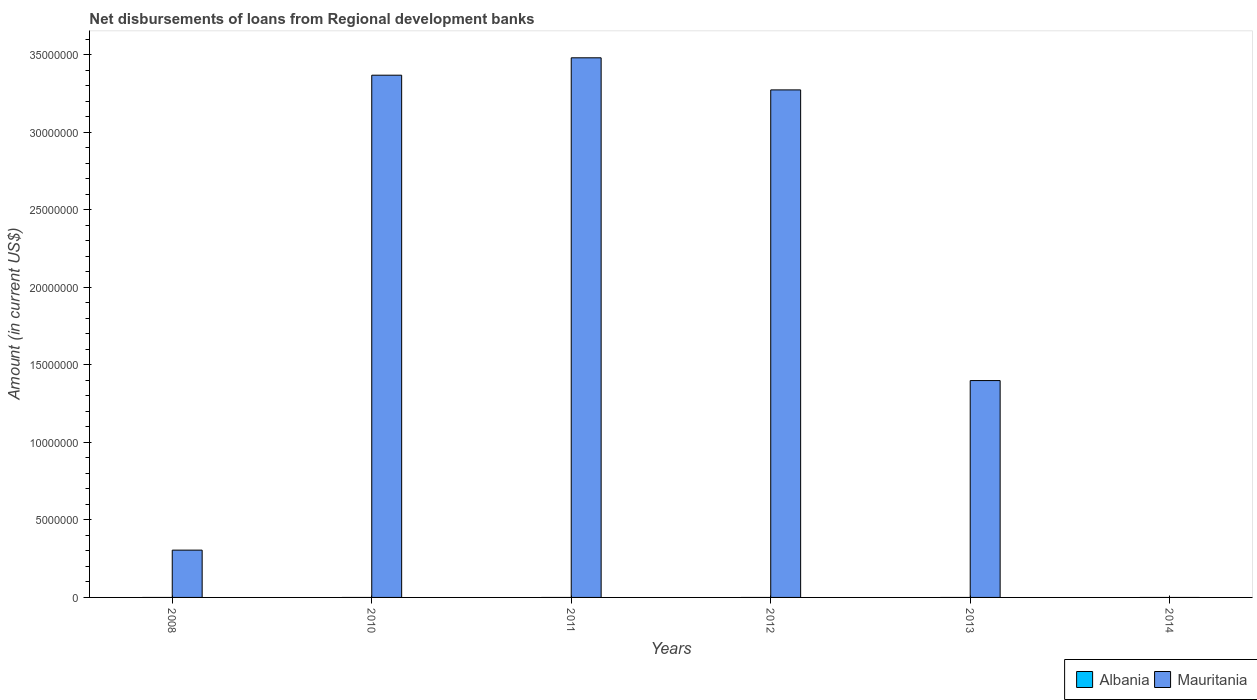Are the number of bars per tick equal to the number of legend labels?
Make the answer very short. No. How many bars are there on the 2nd tick from the left?
Your answer should be very brief. 1. How many bars are there on the 3rd tick from the right?
Provide a succinct answer. 1. What is the label of the 6th group of bars from the left?
Offer a very short reply. 2014. In how many cases, is the number of bars for a given year not equal to the number of legend labels?
Give a very brief answer. 6. What is the amount of disbursements of loans from regional development banks in Mauritania in 2010?
Your answer should be very brief. 3.37e+07. Across all years, what is the maximum amount of disbursements of loans from regional development banks in Mauritania?
Keep it short and to the point. 3.48e+07. In which year was the amount of disbursements of loans from regional development banks in Mauritania maximum?
Provide a succinct answer. 2011. What is the total amount of disbursements of loans from regional development banks in Mauritania in the graph?
Ensure brevity in your answer.  1.18e+08. What is the difference between the amount of disbursements of loans from regional development banks in Mauritania in 2008 and that in 2011?
Make the answer very short. -3.18e+07. What is the difference between the amount of disbursements of loans from regional development banks in Mauritania in 2011 and the amount of disbursements of loans from regional development banks in Albania in 2012?
Your answer should be very brief. 3.48e+07. What is the average amount of disbursements of loans from regional development banks in Albania per year?
Keep it short and to the point. 0. In how many years, is the amount of disbursements of loans from regional development banks in Albania greater than 8000000 US$?
Ensure brevity in your answer.  0. What is the ratio of the amount of disbursements of loans from regional development banks in Mauritania in 2010 to that in 2013?
Offer a terse response. 2.41. Is the amount of disbursements of loans from regional development banks in Mauritania in 2011 less than that in 2012?
Offer a very short reply. No. What is the difference between the highest and the second highest amount of disbursements of loans from regional development banks in Mauritania?
Keep it short and to the point. 1.12e+06. What is the difference between the highest and the lowest amount of disbursements of loans from regional development banks in Mauritania?
Your answer should be very brief. 3.48e+07. In how many years, is the amount of disbursements of loans from regional development banks in Albania greater than the average amount of disbursements of loans from regional development banks in Albania taken over all years?
Keep it short and to the point. 0. Is the sum of the amount of disbursements of loans from regional development banks in Mauritania in 2012 and 2013 greater than the maximum amount of disbursements of loans from regional development banks in Albania across all years?
Your answer should be very brief. Yes. Are the values on the major ticks of Y-axis written in scientific E-notation?
Provide a short and direct response. No. Does the graph contain grids?
Ensure brevity in your answer.  No. Where does the legend appear in the graph?
Your response must be concise. Bottom right. What is the title of the graph?
Make the answer very short. Net disbursements of loans from Regional development banks. Does "Lesotho" appear as one of the legend labels in the graph?
Give a very brief answer. No. What is the label or title of the X-axis?
Offer a terse response. Years. What is the label or title of the Y-axis?
Offer a very short reply. Amount (in current US$). What is the Amount (in current US$) in Albania in 2008?
Provide a short and direct response. 0. What is the Amount (in current US$) in Mauritania in 2008?
Your answer should be very brief. 3.05e+06. What is the Amount (in current US$) of Albania in 2010?
Your response must be concise. 0. What is the Amount (in current US$) of Mauritania in 2010?
Make the answer very short. 3.37e+07. What is the Amount (in current US$) in Albania in 2011?
Keep it short and to the point. 0. What is the Amount (in current US$) of Mauritania in 2011?
Your response must be concise. 3.48e+07. What is the Amount (in current US$) in Albania in 2012?
Make the answer very short. 0. What is the Amount (in current US$) of Mauritania in 2012?
Ensure brevity in your answer.  3.27e+07. What is the Amount (in current US$) in Albania in 2013?
Your answer should be very brief. 0. What is the Amount (in current US$) of Mauritania in 2013?
Your response must be concise. 1.40e+07. What is the Amount (in current US$) in Albania in 2014?
Your response must be concise. 0. What is the Amount (in current US$) of Mauritania in 2014?
Provide a succinct answer. 0. Across all years, what is the maximum Amount (in current US$) of Mauritania?
Offer a very short reply. 3.48e+07. Across all years, what is the minimum Amount (in current US$) of Mauritania?
Offer a very short reply. 0. What is the total Amount (in current US$) in Albania in the graph?
Your response must be concise. 0. What is the total Amount (in current US$) of Mauritania in the graph?
Keep it short and to the point. 1.18e+08. What is the difference between the Amount (in current US$) of Mauritania in 2008 and that in 2010?
Offer a very short reply. -3.06e+07. What is the difference between the Amount (in current US$) in Mauritania in 2008 and that in 2011?
Your answer should be very brief. -3.18e+07. What is the difference between the Amount (in current US$) in Mauritania in 2008 and that in 2012?
Offer a terse response. -2.97e+07. What is the difference between the Amount (in current US$) of Mauritania in 2008 and that in 2013?
Provide a short and direct response. -1.09e+07. What is the difference between the Amount (in current US$) in Mauritania in 2010 and that in 2011?
Provide a succinct answer. -1.12e+06. What is the difference between the Amount (in current US$) in Mauritania in 2010 and that in 2012?
Provide a succinct answer. 9.49e+05. What is the difference between the Amount (in current US$) of Mauritania in 2010 and that in 2013?
Your answer should be very brief. 1.97e+07. What is the difference between the Amount (in current US$) in Mauritania in 2011 and that in 2012?
Provide a succinct answer. 2.07e+06. What is the difference between the Amount (in current US$) of Mauritania in 2011 and that in 2013?
Provide a short and direct response. 2.08e+07. What is the difference between the Amount (in current US$) of Mauritania in 2012 and that in 2013?
Provide a short and direct response. 1.88e+07. What is the average Amount (in current US$) of Albania per year?
Your answer should be very brief. 0. What is the average Amount (in current US$) of Mauritania per year?
Your response must be concise. 1.97e+07. What is the ratio of the Amount (in current US$) in Mauritania in 2008 to that in 2010?
Offer a very short reply. 0.09. What is the ratio of the Amount (in current US$) in Mauritania in 2008 to that in 2011?
Your answer should be very brief. 0.09. What is the ratio of the Amount (in current US$) of Mauritania in 2008 to that in 2012?
Your response must be concise. 0.09. What is the ratio of the Amount (in current US$) of Mauritania in 2008 to that in 2013?
Make the answer very short. 0.22. What is the ratio of the Amount (in current US$) in Mauritania in 2010 to that in 2011?
Make the answer very short. 0.97. What is the ratio of the Amount (in current US$) of Mauritania in 2010 to that in 2012?
Your answer should be compact. 1.03. What is the ratio of the Amount (in current US$) of Mauritania in 2010 to that in 2013?
Provide a short and direct response. 2.41. What is the ratio of the Amount (in current US$) of Mauritania in 2011 to that in 2012?
Make the answer very short. 1.06. What is the ratio of the Amount (in current US$) in Mauritania in 2011 to that in 2013?
Give a very brief answer. 2.49. What is the ratio of the Amount (in current US$) in Mauritania in 2012 to that in 2013?
Your answer should be very brief. 2.34. What is the difference between the highest and the second highest Amount (in current US$) in Mauritania?
Offer a terse response. 1.12e+06. What is the difference between the highest and the lowest Amount (in current US$) in Mauritania?
Ensure brevity in your answer.  3.48e+07. 